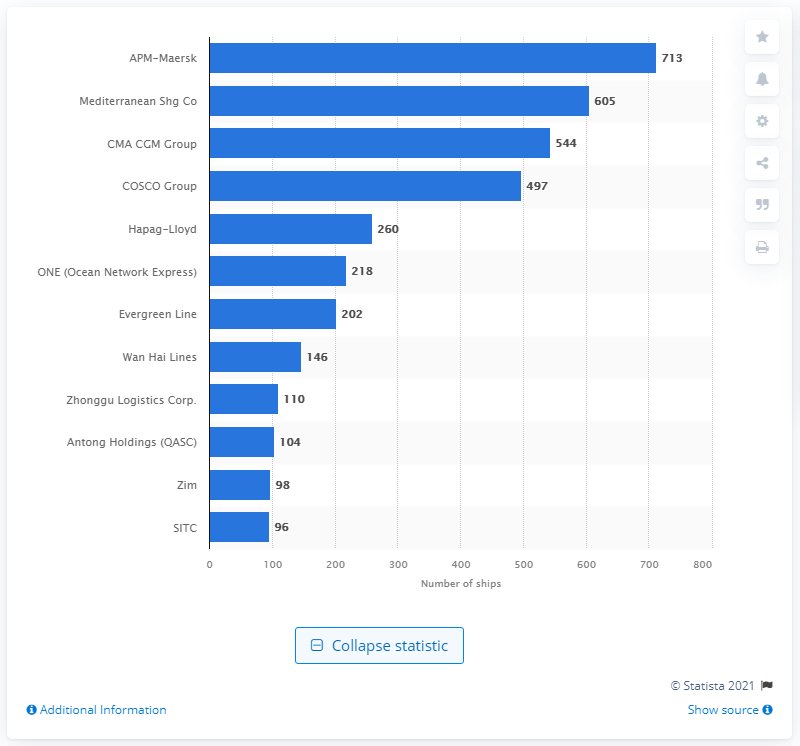Highlight a few significant elements in this photo. As of our records, APM-Maersk had a total of 713 container ships in its fleet. 